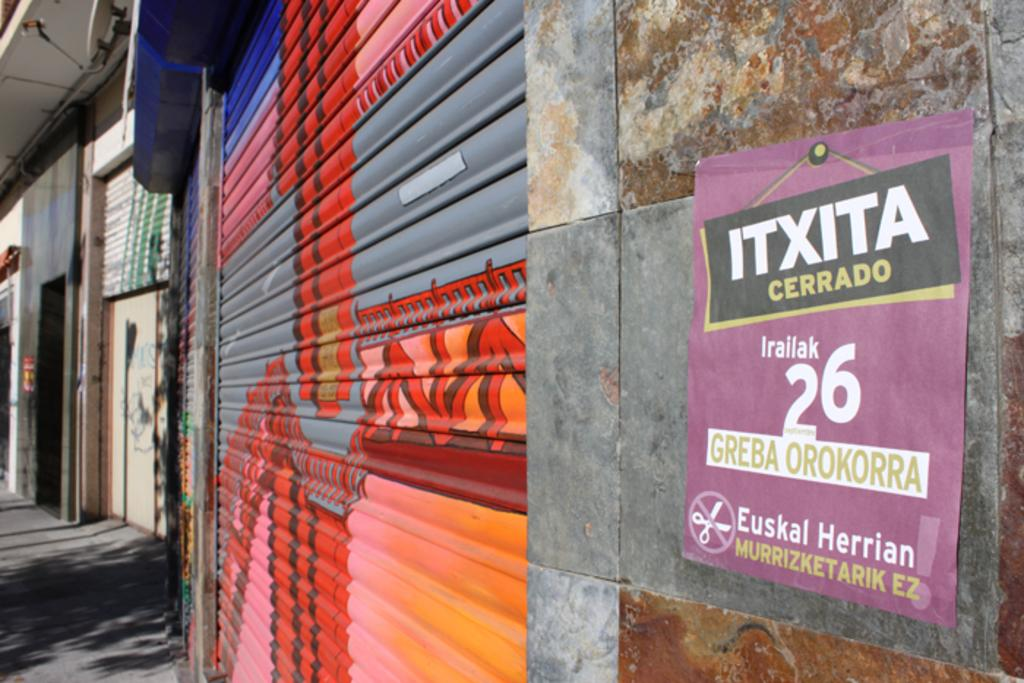What is the main subject of the image? The main subject of the image is shots. Can you describe any additional elements in the image? Yes, there are posts to the wall in the image. What type of lock is used to secure the bed in the image? There is no bed present in the image, so it is not possible to determine what type of lock might be used to secure it. 